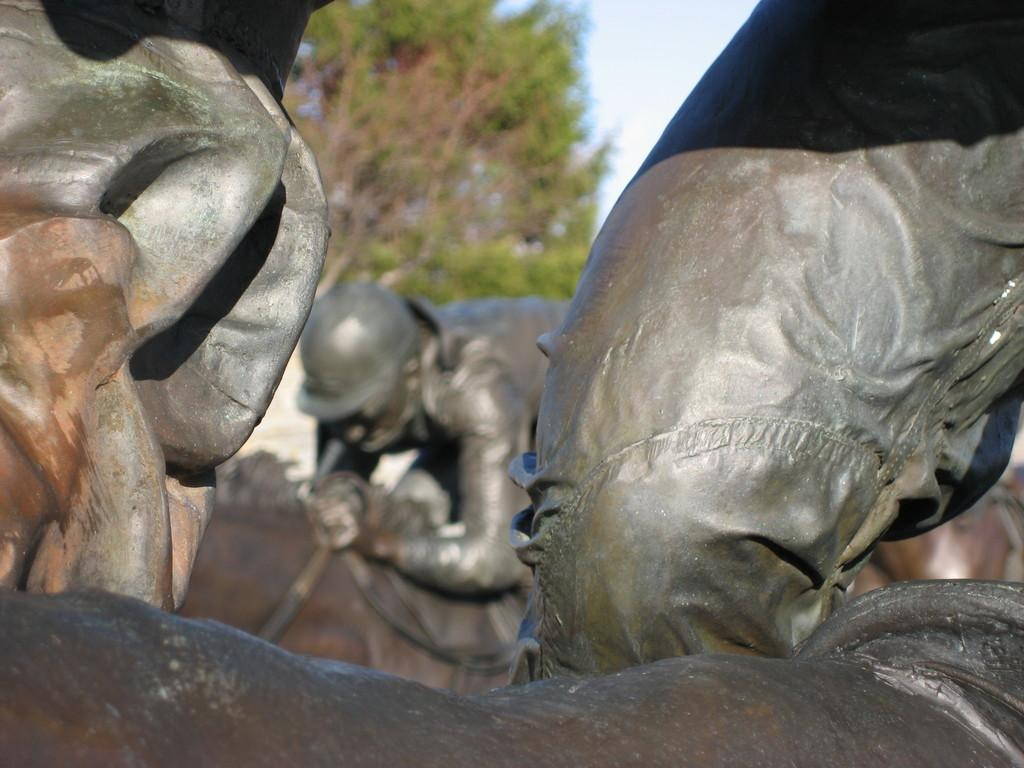What is the main subject of the image? There is a statue in the image. What is the statue depicting? The statue depicts a man riding a horse. What other object can be seen in the image? There is a tree in the image. How would you describe the sky in the image? The sky is cloudy in the image. How many shops are visible in the image? There are no shops present in the image. What is the size of the snakes coiled around the statue's base? There are no snakes present in the image; the statue depicts a man riding a horse. 